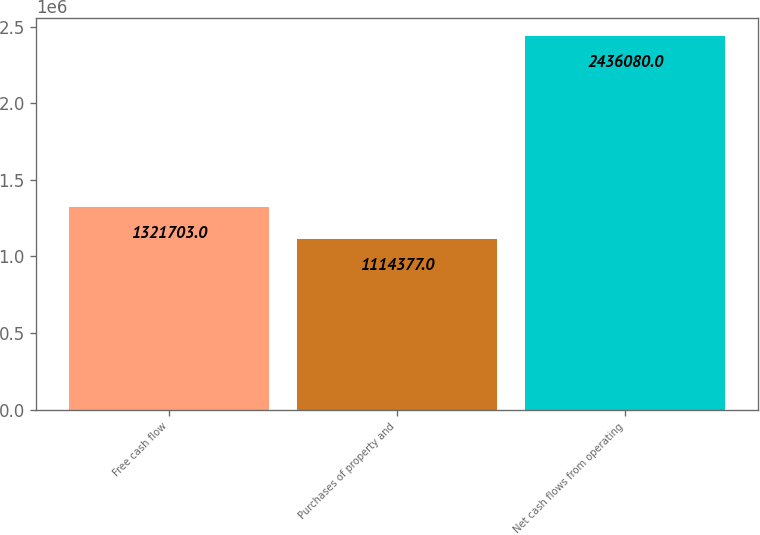<chart> <loc_0><loc_0><loc_500><loc_500><bar_chart><fcel>Free cash flow<fcel>Purchases of property and<fcel>Net cash flows from operating<nl><fcel>1.3217e+06<fcel>1.11438e+06<fcel>2.43608e+06<nl></chart> 